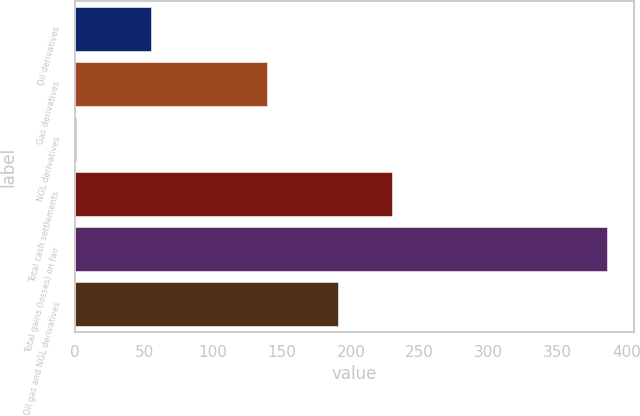Convert chart. <chart><loc_0><loc_0><loc_500><loc_500><bar_chart><fcel>Oil derivatives<fcel>Gas derivatives<fcel>NGL derivatives<fcel>Total cash settlements<fcel>Total gains (losses) on fair<fcel>Oil gas and NGL derivatives<nl><fcel>55<fcel>139<fcel>1<fcel>229.5<fcel>386<fcel>191<nl></chart> 